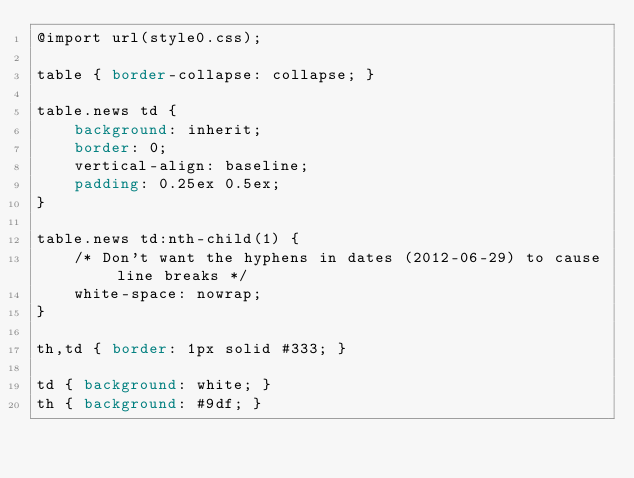<code> <loc_0><loc_0><loc_500><loc_500><_CSS_>@import url(style0.css);

table { border-collapse: collapse; }

table.news td {
    background: inherit;
    border: 0;
    vertical-align: baseline;
    padding: 0.25ex 0.5ex;
}

table.news td:nth-child(1) {
    /* Don't want the hyphens in dates (2012-06-29) to cause line breaks */
    white-space: nowrap;
}

th,td { border: 1px solid #333; }

td { background: white; }
th { background: #9df; }
</code> 